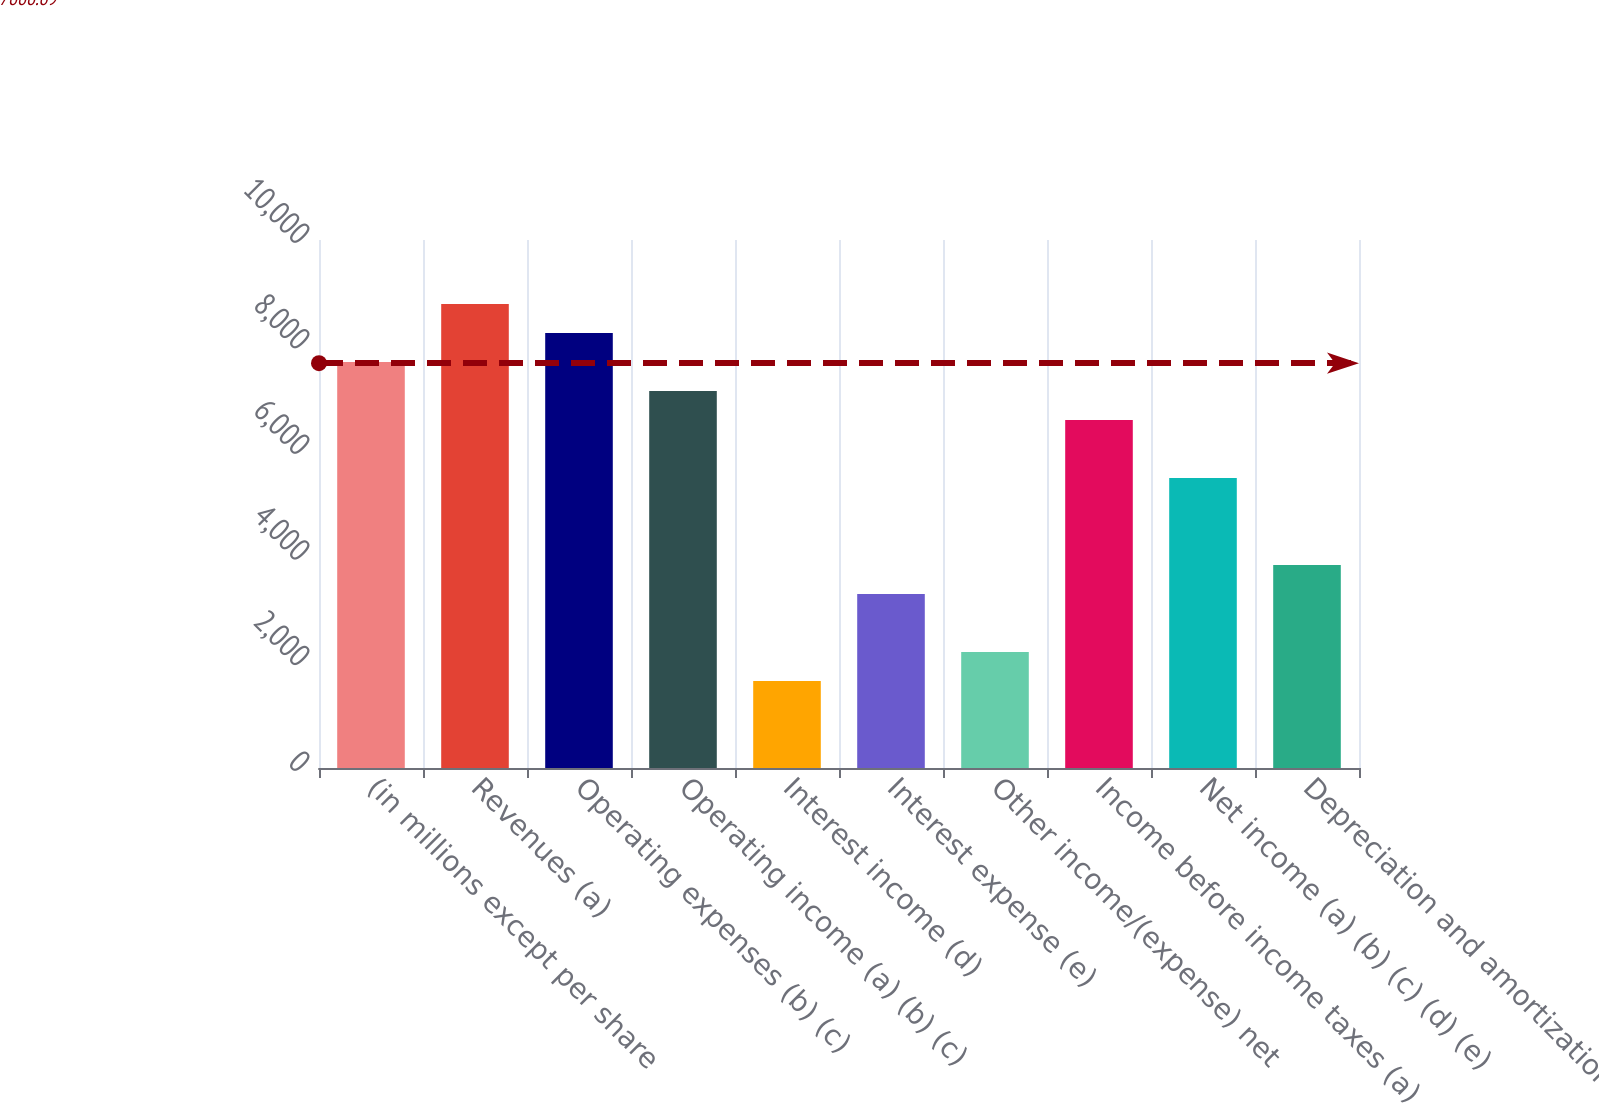Convert chart. <chart><loc_0><loc_0><loc_500><loc_500><bar_chart><fcel>(in millions except per share<fcel>Revenues (a)<fcel>Operating expenses (b) (c)<fcel>Operating income (a) (b) (c)<fcel>Interest income (d)<fcel>Interest expense (e)<fcel>Other income/(expense) net<fcel>Income before income taxes (a)<fcel>Net income (a) (b) (c) (d) (e)<fcel>Depreciation and amortization<nl><fcel>7687.85<fcel>8786.07<fcel>8236.96<fcel>7138.74<fcel>1647.64<fcel>3294.97<fcel>2196.75<fcel>6589.63<fcel>5491.41<fcel>3844.08<nl></chart> 